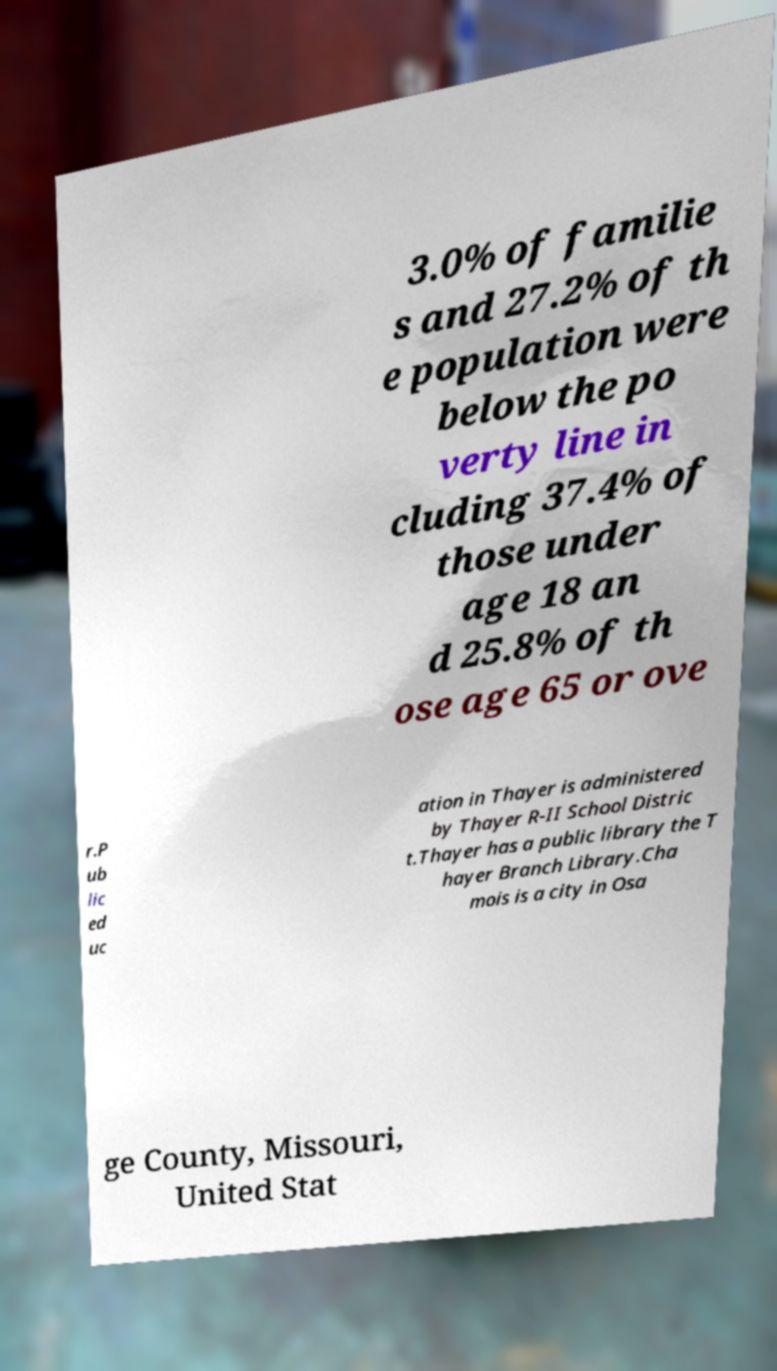Could you assist in decoding the text presented in this image and type it out clearly? 3.0% of familie s and 27.2% of th e population were below the po verty line in cluding 37.4% of those under age 18 an d 25.8% of th ose age 65 or ove r.P ub lic ed uc ation in Thayer is administered by Thayer R-II School Distric t.Thayer has a public library the T hayer Branch Library.Cha mois is a city in Osa ge County, Missouri, United Stat 